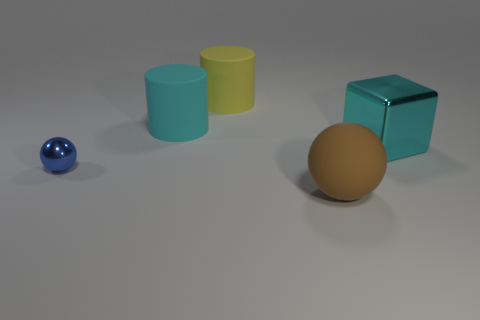There is a cylinder that is the same color as the big block; what is its size?
Your response must be concise. Large. Are there any big cyan metal things left of the big cyan thing behind the shiny block?
Your answer should be compact. No. Is the number of blue metallic things that are in front of the large brown rubber thing less than the number of small metallic spheres that are in front of the tiny sphere?
Offer a terse response. No. Is there any other thing that is the same size as the yellow rubber cylinder?
Provide a succinct answer. Yes. What is the shape of the large yellow object?
Offer a very short reply. Cylinder. There is a cylinder that is behind the large cyan rubber thing; what material is it?
Make the answer very short. Rubber. There is a cylinder that is right of the large cyan thing on the left side of the big thing that is in front of the tiny ball; how big is it?
Your answer should be compact. Large. Is the material of the cylinder behind the cyan matte cylinder the same as the ball that is in front of the blue ball?
Provide a succinct answer. Yes. What number of other things are there of the same color as the big metallic block?
Offer a very short reply. 1. How many things are either cyan objects on the left side of the big sphere or things that are right of the tiny thing?
Ensure brevity in your answer.  4. 